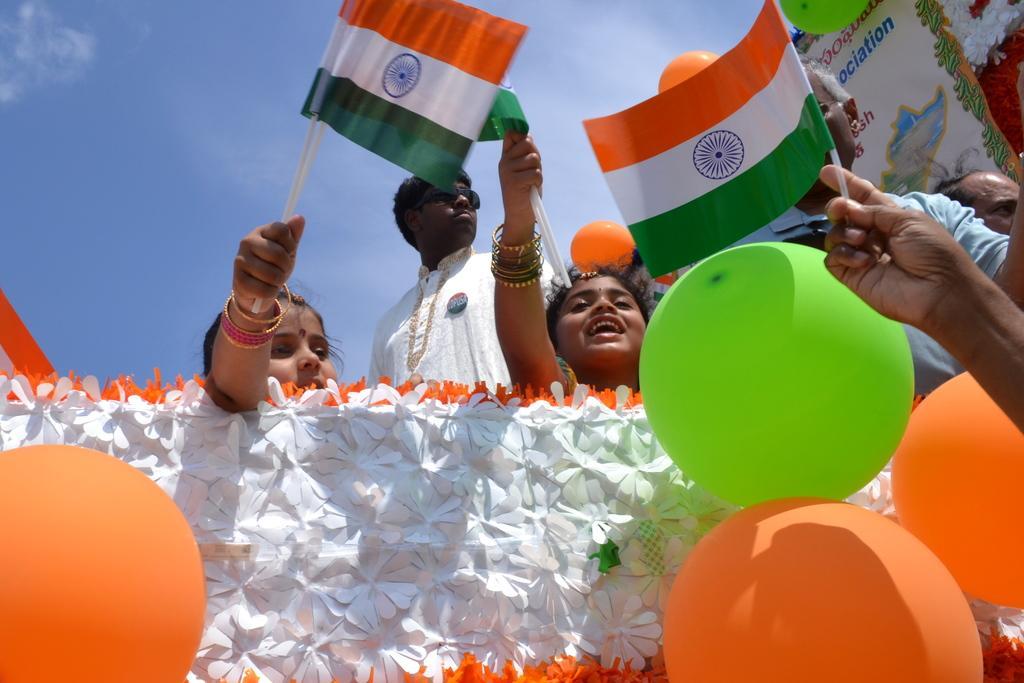How would you summarize this image in a sentence or two? In this image in front there are balloons. There are white color flowers. There are people holding flags, banner. In the background of the image there is sky. 